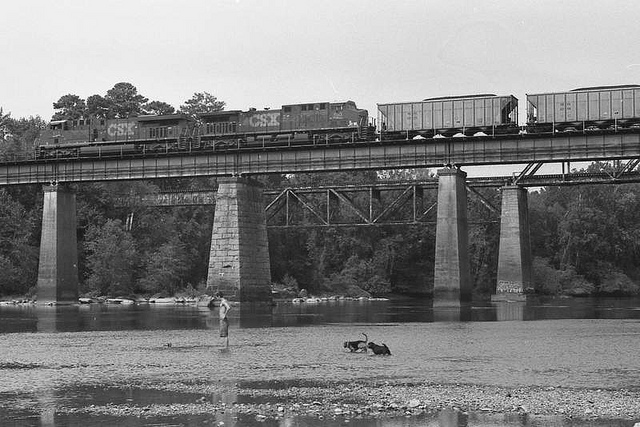<image>What kind of animals are visible? I am not sure what kind of animals are visible. However, the answers suggest it could be dogs, cats or birds. What kind of animals are visible? I am not sure what kind of animals are visible. It can be seen dogs, birds or cats. 